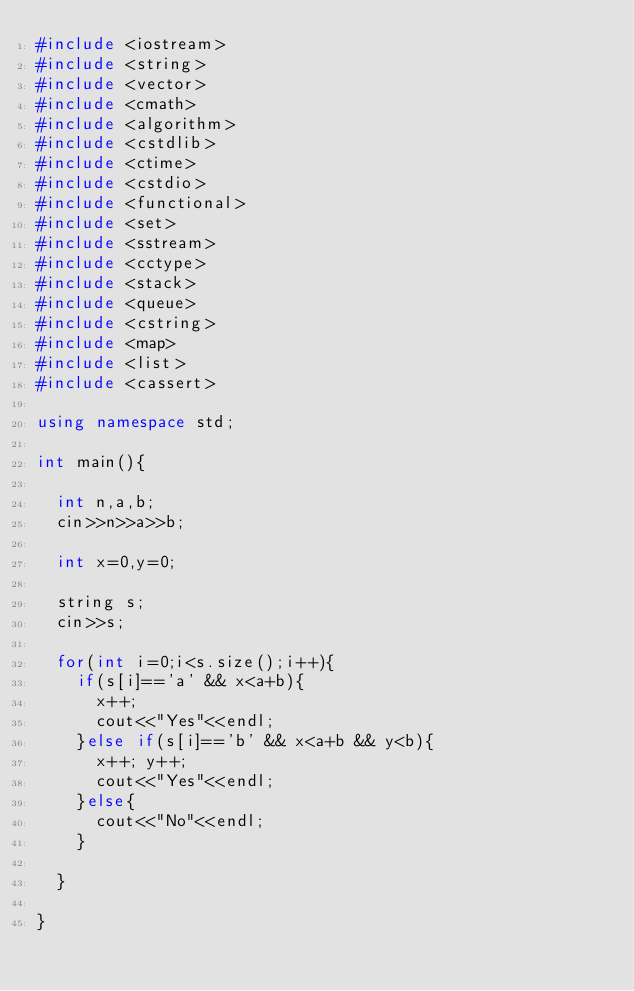<code> <loc_0><loc_0><loc_500><loc_500><_C++_>#include <iostream> 
#include <string> 
#include <vector> 
#include <cmath> 
#include <algorithm> 
#include <cstdlib> 
#include <ctime> 
#include <cstdio> 
#include <functional> 
#include <set> 
#include <sstream> 
#include <cctype>
#include <stack>
#include <queue>
#include <cstring>
#include <map>
#include <list>
#include <cassert>
 
using namespace std; 

int main(){

	int n,a,b;
	cin>>n>>a>>b;

	int x=0,y=0;

	string s;
	cin>>s;

	for(int i=0;i<s.size();i++){
		if(s[i]=='a' && x<a+b){
			x++;
			cout<<"Yes"<<endl;
		}else if(s[i]=='b' && x<a+b && y<b){
			x++; y++;
			cout<<"Yes"<<endl;
		}else{
			cout<<"No"<<endl;
		}

	}

}
</code> 